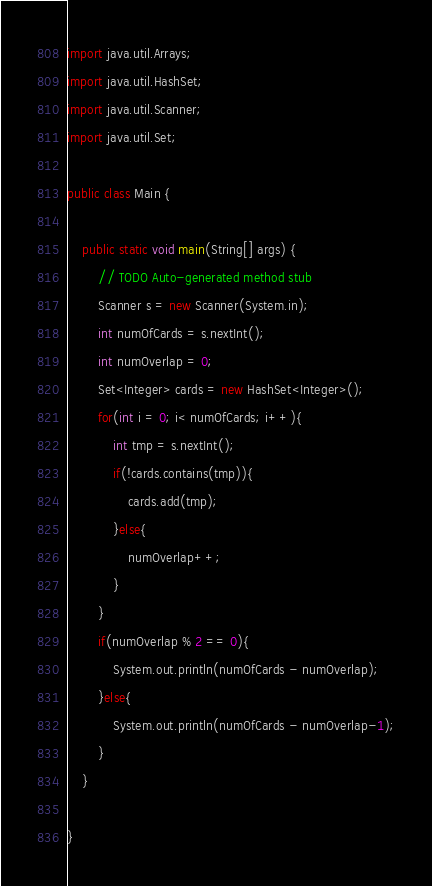<code> <loc_0><loc_0><loc_500><loc_500><_Java_>import java.util.Arrays;
import java.util.HashSet;
import java.util.Scanner;
import java.util.Set;

public class Main {

	public static void main(String[] args) {
		// TODO Auto-generated method stub
		Scanner s = new Scanner(System.in);
		int numOfCards = s.nextInt();
		int numOverlap = 0;
		Set<Integer> cards = new HashSet<Integer>();
		for(int i = 0; i< numOfCards; i++){
			int tmp = s.nextInt();
			if(!cards.contains(tmp)){
				cards.add(tmp);
			}else{
				numOverlap++;
			}
		}
		if(numOverlap % 2 == 0){
			System.out.println(numOfCards - numOverlap);
		}else{
			System.out.println(numOfCards - numOverlap-1);
		}
	}

}
</code> 